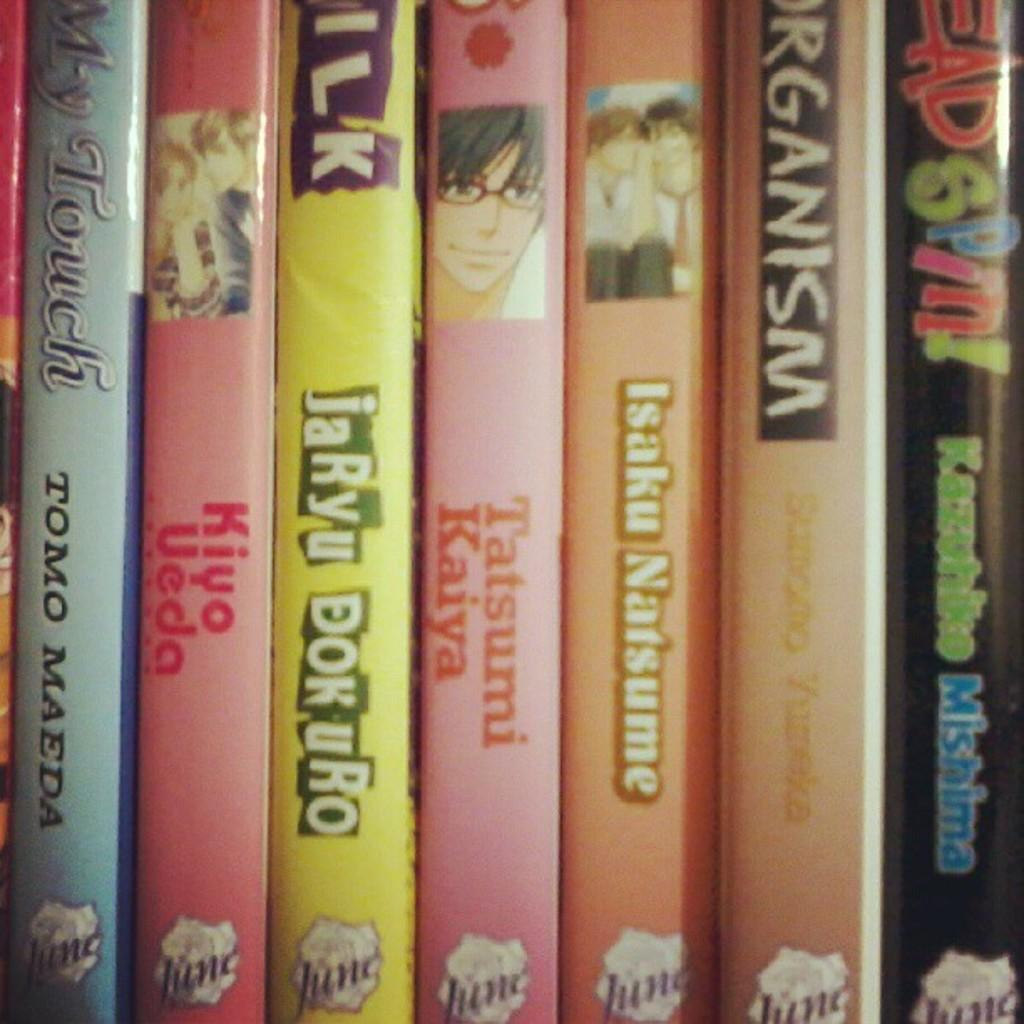<image>
Give a short and clear explanation of the subsequent image. several books are lined up together, including Head spin 